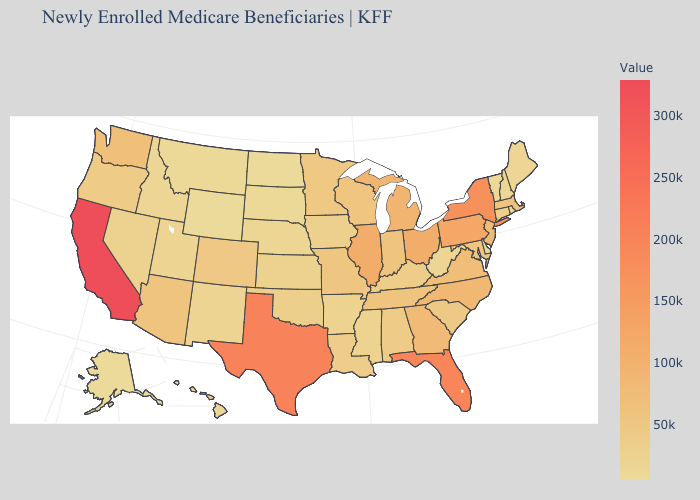Which states have the lowest value in the USA?
Answer briefly. Wyoming. Among the states that border Wisconsin , which have the highest value?
Quick response, please. Illinois. Does Idaho have the lowest value in the USA?
Answer briefly. No. Does Wyoming have the lowest value in the USA?
Concise answer only. Yes. Does Wyoming have the lowest value in the West?
Keep it brief. Yes. Which states have the lowest value in the USA?
Write a very short answer. Wyoming. 